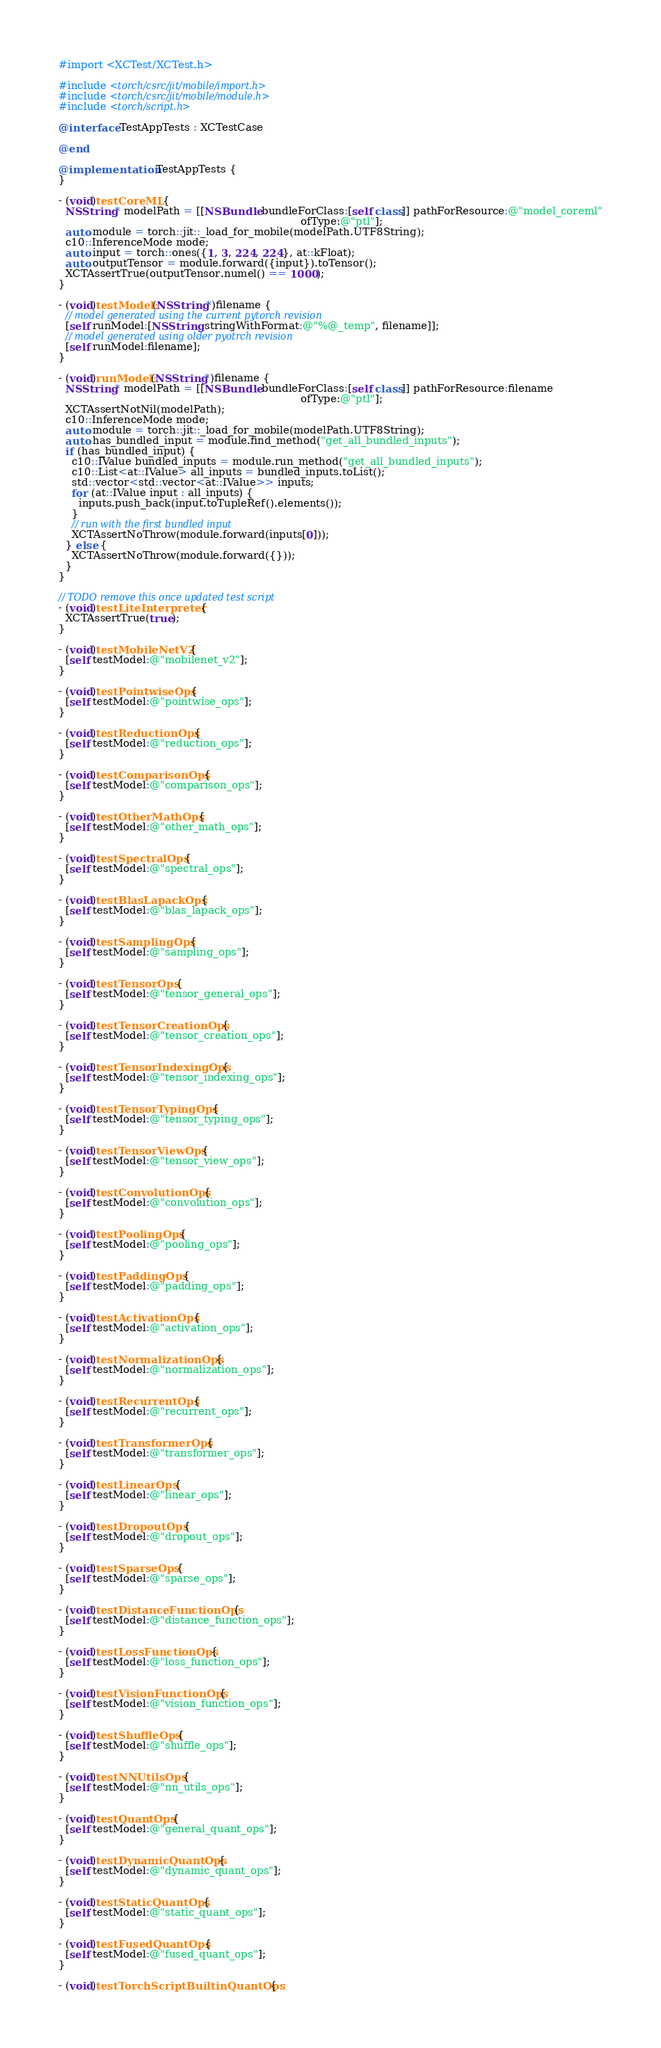Convert code to text. <code><loc_0><loc_0><loc_500><loc_500><_ObjectiveC_>#import <XCTest/XCTest.h>

#include <torch/csrc/jit/mobile/import.h>
#include <torch/csrc/jit/mobile/module.h>
#include <torch/script.h>

@interface TestAppTests : XCTestCase

@end

@implementation TestAppTests {
}

- (void)testCoreML {
  NSString* modelPath = [[NSBundle bundleForClass:[self class]] pathForResource:@"model_coreml"
                                                                         ofType:@"ptl"];
  auto module = torch::jit::_load_for_mobile(modelPath.UTF8String);
  c10::InferenceMode mode;
  auto input = torch::ones({1, 3, 224, 224}, at::kFloat);
  auto outputTensor = module.forward({input}).toTensor();
  XCTAssertTrue(outputTensor.numel() == 1000);
}

- (void)testModel:(NSString*)filename {
  // model generated using the current pytorch revision
  [self runModel:[NSString stringWithFormat:@"%@_temp", filename]];
  // model generated using older pyotrch revision
  [self runModel:filename];
}

- (void)runModel:(NSString*)filename {
  NSString* modelPath = [[NSBundle bundleForClass:[self class]] pathForResource:filename
                                                                         ofType:@"ptl"];
  XCTAssertNotNil(modelPath);
  c10::InferenceMode mode;
  auto module = torch::jit::_load_for_mobile(modelPath.UTF8String);
  auto has_bundled_input = module.find_method("get_all_bundled_inputs");
  if (has_bundled_input) {
    c10::IValue bundled_inputs = module.run_method("get_all_bundled_inputs");
    c10::List<at::IValue> all_inputs = bundled_inputs.toList();
    std::vector<std::vector<at::IValue>> inputs;
    for (at::IValue input : all_inputs) {
      inputs.push_back(input.toTupleRef().elements());
    }
    // run with the first bundled input
    XCTAssertNoThrow(module.forward(inputs[0]));
  } else {
    XCTAssertNoThrow(module.forward({}));
  }
}

// TODO remove this once updated test script
- (void)testLiteInterpreter {
  XCTAssertTrue(true);
}

- (void)testMobileNetV2 {
  [self testModel:@"mobilenet_v2"];
}

- (void)testPointwiseOps {
  [self testModel:@"pointwise_ops"];
}

- (void)testReductionOps {
  [self testModel:@"reduction_ops"];
}

- (void)testComparisonOps {
  [self testModel:@"comparison_ops"];
}

- (void)testOtherMathOps {
  [self testModel:@"other_math_ops"];
}

- (void)testSpectralOps {
  [self testModel:@"spectral_ops"];
}

- (void)testBlasLapackOps {
  [self testModel:@"blas_lapack_ops"];
}

- (void)testSamplingOps {
  [self testModel:@"sampling_ops"];
}

- (void)testTensorOps {
  [self testModel:@"tensor_general_ops"];
}

- (void)testTensorCreationOps {
  [self testModel:@"tensor_creation_ops"];
}

- (void)testTensorIndexingOps {
  [self testModel:@"tensor_indexing_ops"];
}

- (void)testTensorTypingOps {
  [self testModel:@"tensor_typing_ops"];
}

- (void)testTensorViewOps {
  [self testModel:@"tensor_view_ops"];
}

- (void)testConvolutionOps {
  [self testModel:@"convolution_ops"];
}

- (void)testPoolingOps {
  [self testModel:@"pooling_ops"];
}

- (void)testPaddingOps {
  [self testModel:@"padding_ops"];
}

- (void)testActivationOps {
  [self testModel:@"activation_ops"];
}

- (void)testNormalizationOps {
  [self testModel:@"normalization_ops"];
}

- (void)testRecurrentOps {
  [self testModel:@"recurrent_ops"];
}

- (void)testTransformerOps {
  [self testModel:@"transformer_ops"];
}

- (void)testLinearOps {
  [self testModel:@"linear_ops"];
}

- (void)testDropoutOps {
  [self testModel:@"dropout_ops"];
}

- (void)testSparseOps {
  [self testModel:@"sparse_ops"];
}

- (void)testDistanceFunctionOps {
  [self testModel:@"distance_function_ops"];
}

- (void)testLossFunctionOps {
  [self testModel:@"loss_function_ops"];
}

- (void)testVisionFunctionOps {
  [self testModel:@"vision_function_ops"];
}

- (void)testShuffleOps {
  [self testModel:@"shuffle_ops"];
}

- (void)testNNUtilsOps {
  [self testModel:@"nn_utils_ops"];
}

- (void)testQuantOps {
  [self testModel:@"general_quant_ops"];
}

- (void)testDynamicQuantOps {
  [self testModel:@"dynamic_quant_ops"];
}

- (void)testStaticQuantOps {
  [self testModel:@"static_quant_ops"];
}

- (void)testFusedQuantOps {
  [self testModel:@"fused_quant_ops"];
}

- (void)testTorchScriptBuiltinQuantOps {</code> 